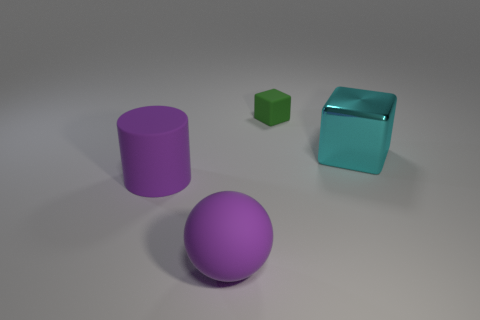How would the scene change if the lighting was dimmer? If the lighting was dimmer, the shadows would become less defined and the overall mood more subdued. The reflective nature of the cyan object might not be as apparent, and the colors of all the objects could appear more muted and less vibrant. 